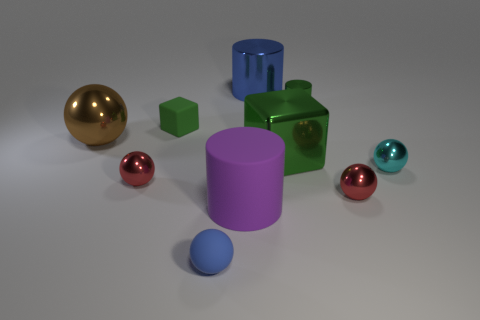What number of metal objects are to the right of the large rubber thing and in front of the big blue cylinder?
Ensure brevity in your answer.  4. How many green things are either tiny metal spheres or small rubber spheres?
Keep it short and to the point. 0. There is a metal cylinder to the right of the big blue metallic thing; is its color the same as the shiny cube on the right side of the green rubber object?
Your response must be concise. Yes. The small matte object that is in front of the small red ball on the right side of the rubber object that is on the left side of the tiny blue object is what color?
Your answer should be compact. Blue. There is a red sphere that is left of the blue ball; is there a matte object to the left of it?
Provide a short and direct response. No. There is a red shiny object on the left side of the tiny green shiny cylinder; is its shape the same as the cyan object?
Keep it short and to the point. Yes. What number of cubes are tiny cyan metal objects or large matte things?
Provide a short and direct response. 0. What number of small green metallic cylinders are there?
Ensure brevity in your answer.  1. There is a blue thing behind the ball behind the tiny cyan shiny ball; what size is it?
Your answer should be very brief. Large. What number of other objects are there of the same size as the green cylinder?
Provide a short and direct response. 5. 